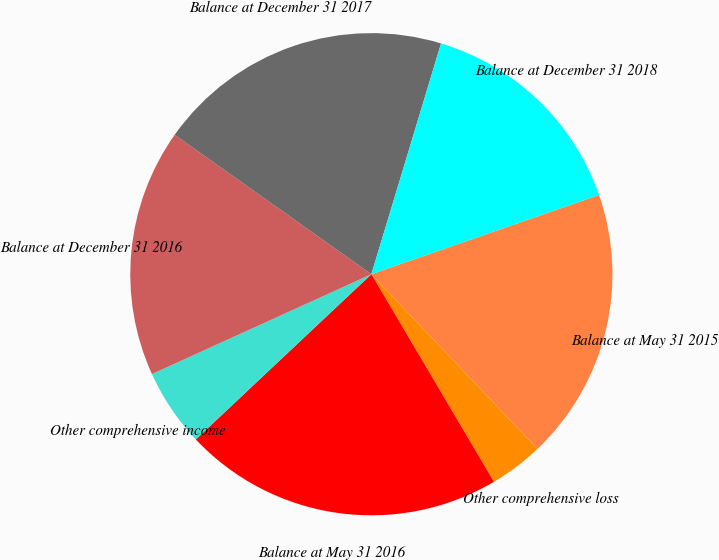Convert chart. <chart><loc_0><loc_0><loc_500><loc_500><pie_chart><fcel>Balance at May 31 2015<fcel>Other comprehensive loss<fcel>Balance at May 31 2016<fcel>Other comprehensive income<fcel>Balance at December 31 2016<fcel>Balance at December 31 2017<fcel>Balance at December 31 2018<nl><fcel>18.23%<fcel>3.61%<fcel>21.47%<fcel>5.22%<fcel>16.61%<fcel>19.85%<fcel>15.0%<nl></chart> 